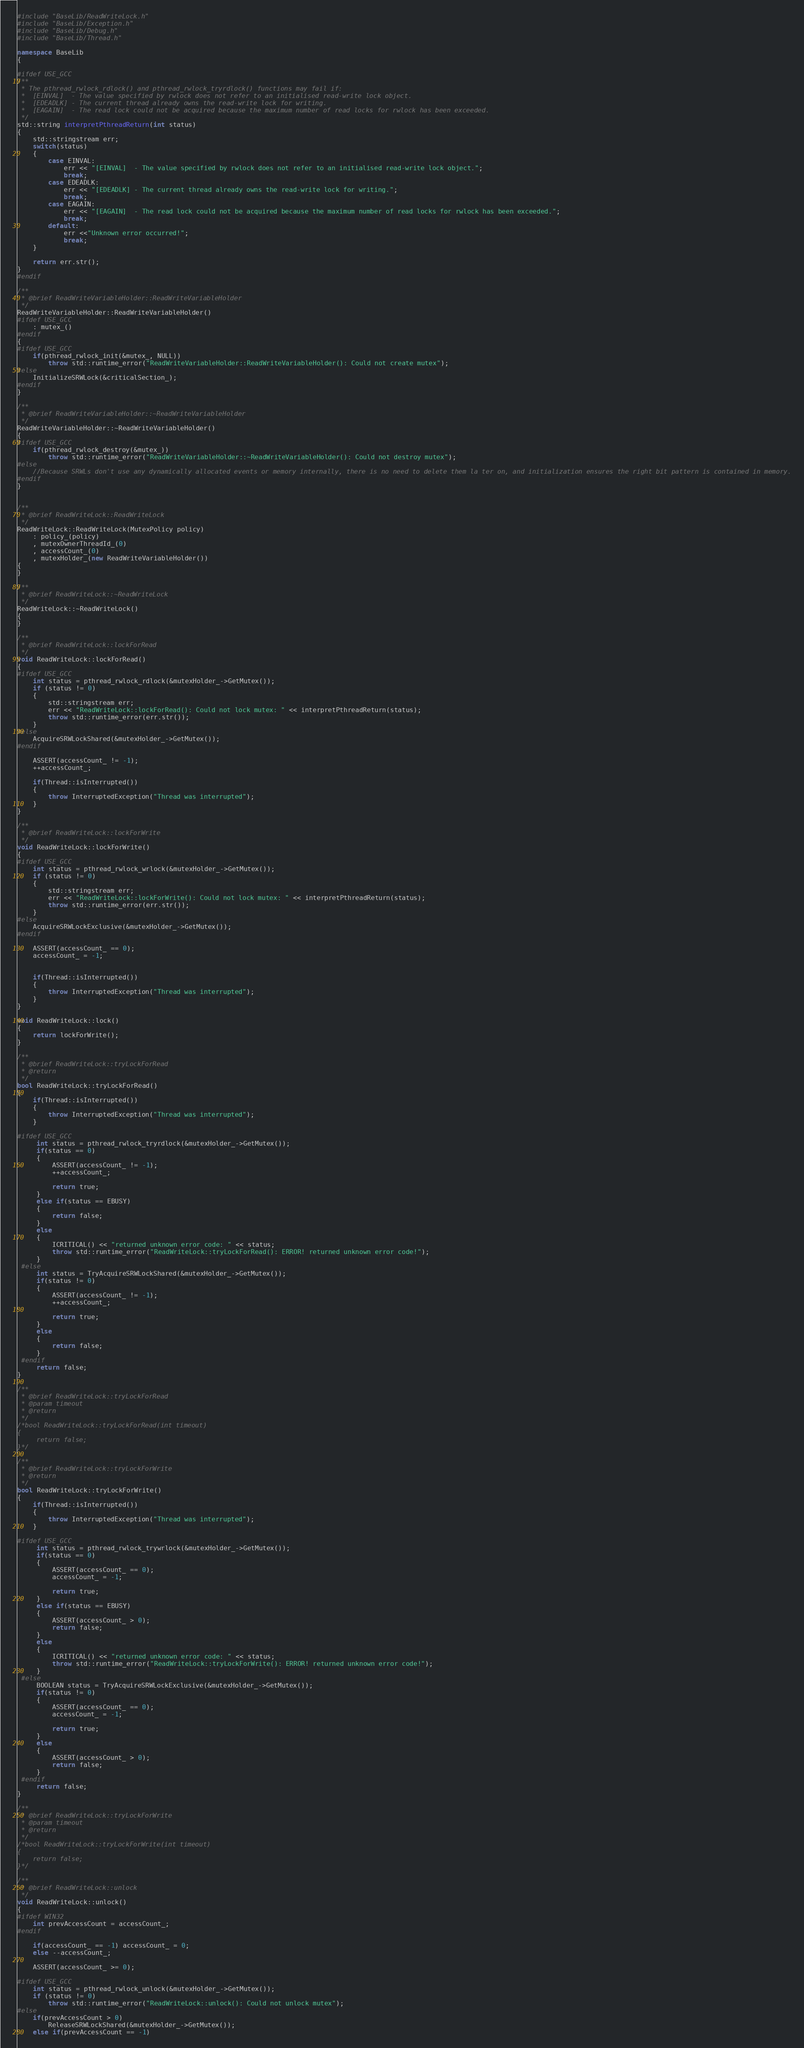Convert code to text. <code><loc_0><loc_0><loc_500><loc_500><_C++_>#include "BaseLib/ReadWriteLock.h"
#include "BaseLib/Exception.h"
#include "BaseLib/Debug.h"
#include "BaseLib/Thread.h"

namespace BaseLib
{

#ifdef USE_GCC
/**
 * The pthread_rwlock_rdlock() and pthread_rwlock_tryrdlock() functions may fail if:
 *  [EINVAL]  - The value specified by rwlock does not refer to an initialised read-write lock object.
 *  [EDEADLK] - The current thread already owns the read-write lock for writing.
 *  [EAGAIN]  - The read lock could not be acquired because the maximum number of read locks for rwlock has been exceeded.
 */
std::string interpretPthreadReturn(int status)
{
    std::stringstream err;
    switch(status)
    {
        case EINVAL:
            err << "[EINVAL]  - The value specified by rwlock does not refer to an initialised read-write lock object.";
            break;
        case EDEADLK:
            err << "[EDEADLK] - The current thread already owns the read-write lock for writing.";
            break;
        case EAGAIN:
            err << "[EAGAIN]  - The read lock could not be acquired because the maximum number of read locks for rwlock has been exceeded.";
            break;
        default:
            err <<"Unknown error occurred!";
            break;
    }

    return err.str();
}
#endif

/**
 * @brief ReadWriteVariableHolder::ReadWriteVariableHolder
 */
ReadWriteVariableHolder::ReadWriteVariableHolder()
#ifdef USE_GCC
    : mutex_()
#endif
{
#ifdef USE_GCC
    if(pthread_rwlock_init(&mutex_, NULL))
        throw std::runtime_error("ReadWriteVariableHolder::ReadWriteVariableHolder(): Could not create mutex");
#else
    InitializeSRWLock(&criticalSection_);
#endif
}

/**
 * @brief ReadWriteVariableHolder::~ReadWriteVariableHolder
 */
ReadWriteVariableHolder::~ReadWriteVariableHolder()
{
#ifdef USE_GCC
    if(pthread_rwlock_destroy(&mutex_))
        throw std::runtime_error("ReadWriteVariableHolder::~ReadWriteVariableHolder(): Could not destroy mutex");
#else
    //Because SRWLs don't use any dynamically allocated events or memory internally, there is no need to delete them la ter on, and initialization ensures the right bit pattern is contained in memory.
#endif
}


/**
 * @brief ReadWriteLock::ReadWriteLock
 */
ReadWriteLock::ReadWriteLock(MutexPolicy policy)
    : policy_(policy)
    , mutexOwnerThreadId_(0)
    , accessCount_(0)
    , mutexHolder_(new ReadWriteVariableHolder())
{
}

/**
 * @brief ReadWriteLock::~ReadWriteLock
 */
ReadWriteLock::~ReadWriteLock()
{
}

/**
 * @brief ReadWriteLock::lockForRead
 */
void ReadWriteLock::lockForRead()
{
#ifdef USE_GCC
    int status = pthread_rwlock_rdlock(&mutexHolder_->GetMutex());
    if (status != 0)
    {
        std::stringstream err;
        err << "ReadWriteLock::lockForRead(): Could not lock mutex: " << interpretPthreadReturn(status);
        throw std::runtime_error(err.str());
    }
#else
    AcquireSRWLockShared(&mutexHolder_->GetMutex());
#endif

    ASSERT(accessCount_ != -1);
    ++accessCount_;

    if(Thread::isInterrupted())
    {
        throw InterruptedException("Thread was interrupted");
    }
}

/**
 * @brief ReadWriteLock::lockForWrite
 */
void ReadWriteLock::lockForWrite()
{
#ifdef USE_GCC
    int status = pthread_rwlock_wrlock(&mutexHolder_->GetMutex());
    if (status != 0)
    {
        std::stringstream err;
        err << "ReadWriteLock::lockForWrite(): Could not lock mutex: " << interpretPthreadReturn(status);
        throw std::runtime_error(err.str());
    }
#else
    AcquireSRWLockExclusive(&mutexHolder_->GetMutex());
#endif

    ASSERT(accessCount_ == 0);
    accessCount_ = -1;


    if(Thread::isInterrupted())
    {
        throw InterruptedException("Thread was interrupted");
    }
}

void ReadWriteLock::lock()
{
    return lockForWrite();
}

/**
 * @brief ReadWriteLock::tryLockForRead
 * @return
 */
bool ReadWriteLock::tryLockForRead()
{
    if(Thread::isInterrupted())
    {
        throw InterruptedException("Thread was interrupted");
    }

#ifdef USE_GCC
     int status = pthread_rwlock_tryrdlock(&mutexHolder_->GetMutex());
     if(status == 0)
     {
         ASSERT(accessCount_ != -1);
         ++accessCount_;

         return true;
     }
     else if(status == EBUSY)
     {
         return false;
     }
     else
     {
         ICRITICAL() << "returned unknown error code: " << status;
         throw std::runtime_error("ReadWriteLock::tryLockForRead(): ERROR! returned unknown error code!");
     }
 #else
     int status = TryAcquireSRWLockShared(&mutexHolder_->GetMutex());
     if(status != 0)
     {
         ASSERT(accessCount_ != -1);
         ++accessCount_;

         return true;
     }
     else
     {
         return false;
     }
 #endif
     return false;
}

/**
 * @brief ReadWriteLock::tryLockForRead
 * @param timeout
 * @return
 */
/*bool ReadWriteLock::tryLockForRead(int timeout)
{
     return false;
}*/

/**
 * @brief ReadWriteLock::tryLockForWrite
 * @return
 */
bool ReadWriteLock::tryLockForWrite()
{
    if(Thread::isInterrupted())
    {
        throw InterruptedException("Thread was interrupted");
    }

#ifdef USE_GCC
     int status = pthread_rwlock_trywrlock(&mutexHolder_->GetMutex());
     if(status == 0)
     {
         ASSERT(accessCount_ == 0);
         accessCount_ = -1;

         return true;
     }
     else if(status == EBUSY)
     {
         ASSERT(accessCount_ > 0);
         return false;
     }
     else
     {
         ICRITICAL() << "returned unknown error code: " << status;
         throw std::runtime_error("ReadWriteLock::tryLockForWrite(): ERROR! returned unknown error code!");
     }
 #else
     BOOLEAN status = TryAcquireSRWLockExclusive(&mutexHolder_->GetMutex());
     if(status != 0)
     {
         ASSERT(accessCount_ == 0);
         accessCount_ = -1;

         return true;
     }
     else
     {
         ASSERT(accessCount_ > 0);
         return false;
     }
 #endif
     return false;
}

/**
 * @brief ReadWriteLock::tryLockForWrite
 * @param timeout
 * @return
 */
/*bool ReadWriteLock::tryLockForWrite(int timeout)
{
    return false;
}*/

/**
 * @brief ReadWriteLock::unlock
 */
void ReadWriteLock::unlock()
{
#ifdef WIN32
    int prevAccessCount = accessCount_;
#endif

    if(accessCount_ == -1) accessCount_ = 0;
    else --accessCount_;

    ASSERT(accessCount_ >= 0);

#ifdef USE_GCC
    int status = pthread_rwlock_unlock(&mutexHolder_->GetMutex());
    if (status != 0)
        throw std::runtime_error("ReadWriteLock::unlock(): Could not unlock mutex");
#else
    if(prevAccessCount > 0)
        ReleaseSRWLockShared(&mutexHolder_->GetMutex());
    else if(prevAccessCount == -1)</code> 